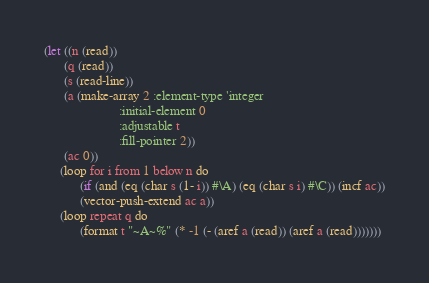<code> <loc_0><loc_0><loc_500><loc_500><_Lisp_>(let ((n (read))
      (q (read))
      (s (read-line))
      (a (make-array 2 :element-type 'integer
                       :initial-element 0
                       :adjustable t
                       :fill-pointer 2))
      (ac 0))
     (loop for i from 1 below n do
           (if (and (eq (char s (1- i)) #\A) (eq (char s i) #\C)) (incf ac))
           (vector-push-extend ac a))
     (loop repeat q do
           (format t "~A~%" (* -1 (- (aref a (read)) (aref a (read)))))))
</code> 